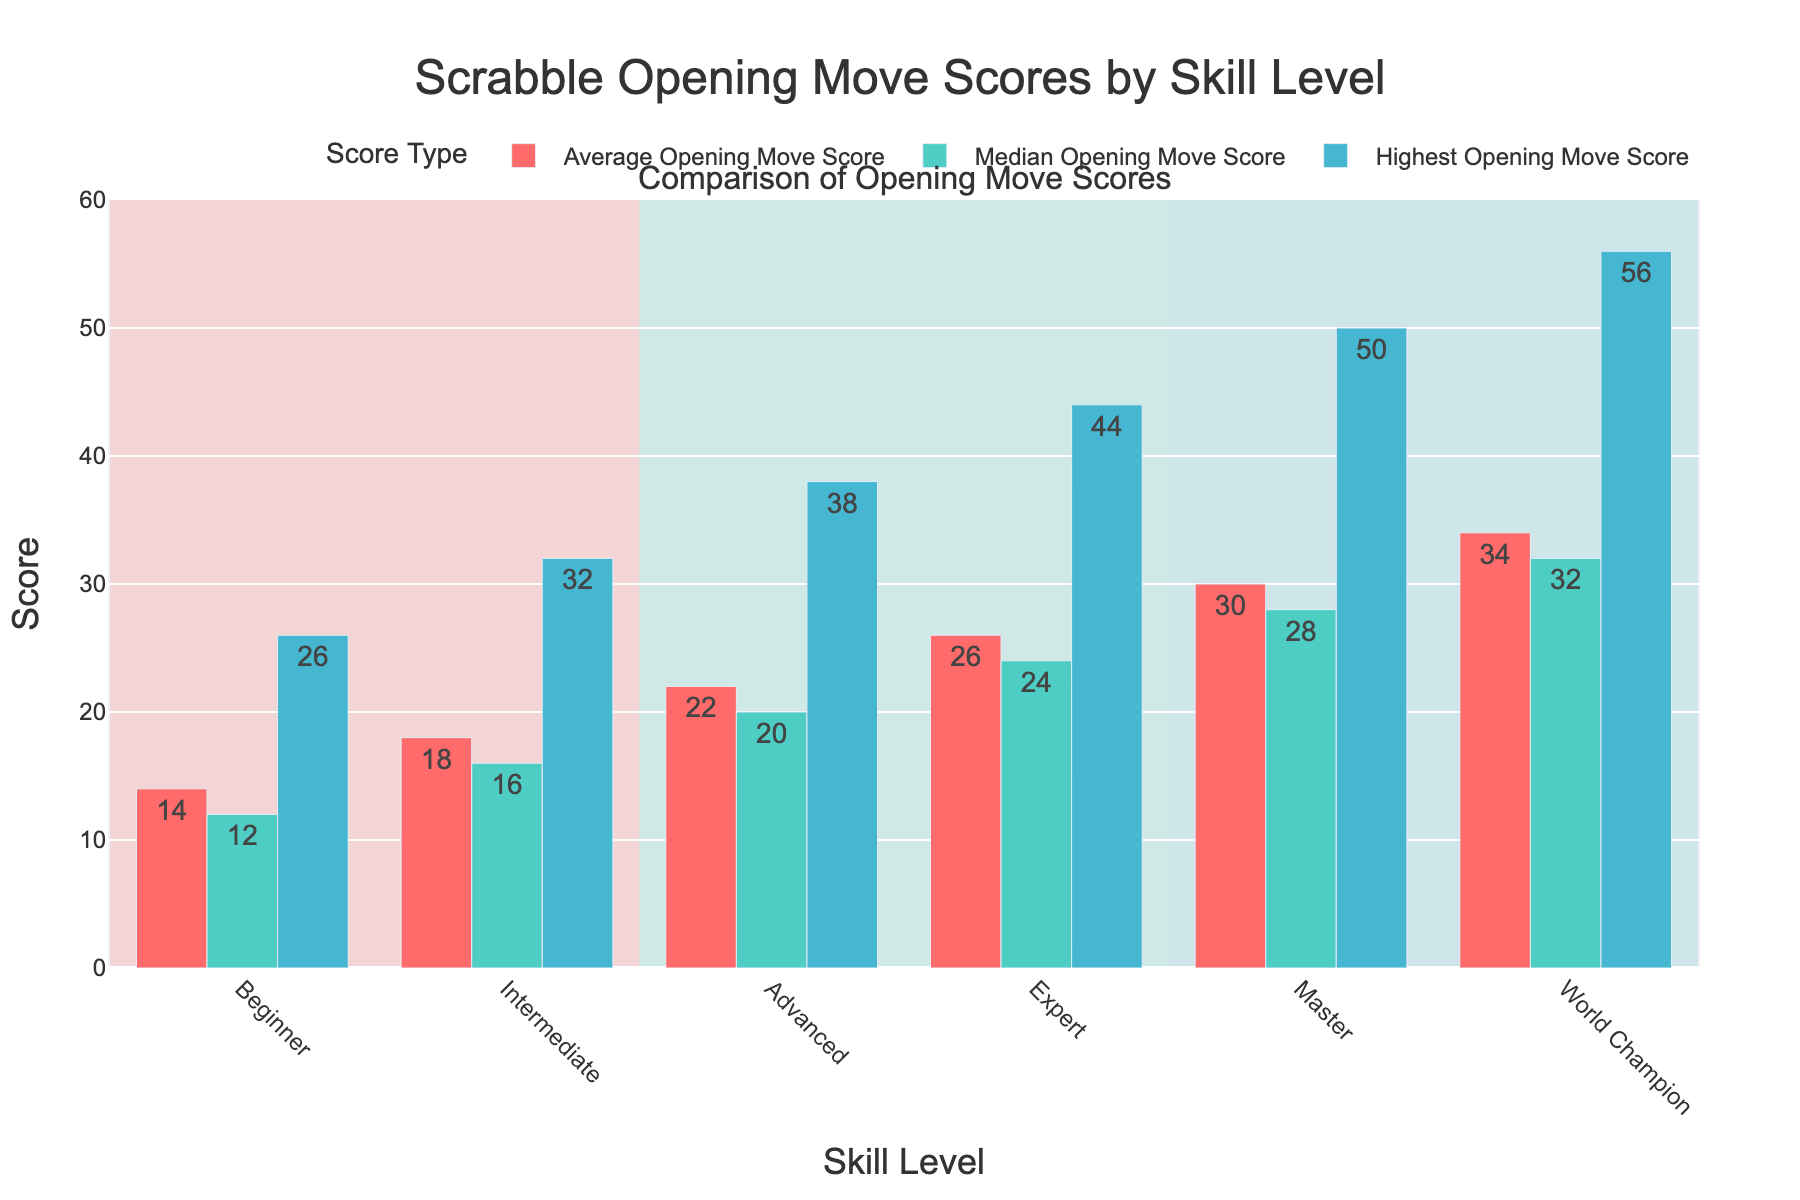what is the difference in the highest opening move score between the beginner and the expert skill levels? To find the difference between the highest opening move scores of beginner and expert players, subtract the beginner's highest score (26) from the expert's highest score (44). 44 - 26 = 18
Answer: 18 Which skill level has the highest average opening move score? Look at the bars representing the average opening move scores. The World Champion skill level has the highest average score (34)
Answer: World Champion What is the average opening move score for Intermediate and Advanced players combined? Add the average scores for Intermediate (18) and Advanced (22), then divide by 2 to find the mean: (18 + 22) / 2 = 20
Answer: 20 Between which two skill levels is the greatest increase in median opening move score? Compare the differences between consecutive skill levels' median scores: Intermediate (16) to Advanced (20) is an increase of 4, Advanced (20) to Expert (24) is an increase of 4, Expert (24) to Master (28) is an increase of 4, and Master (28) to World Champion (32) is an increase of 4. They are all the same, so all pairs have equal greatest increases.
Answer: Intermediate and Advanced What color represents the bars for the highest opening move score? Refer to the figure and identify the color used for the highest opening move score bars, which is consistent across all skill levels. The highest opening move score bars are represented by light blue.
Answer: Light blue 